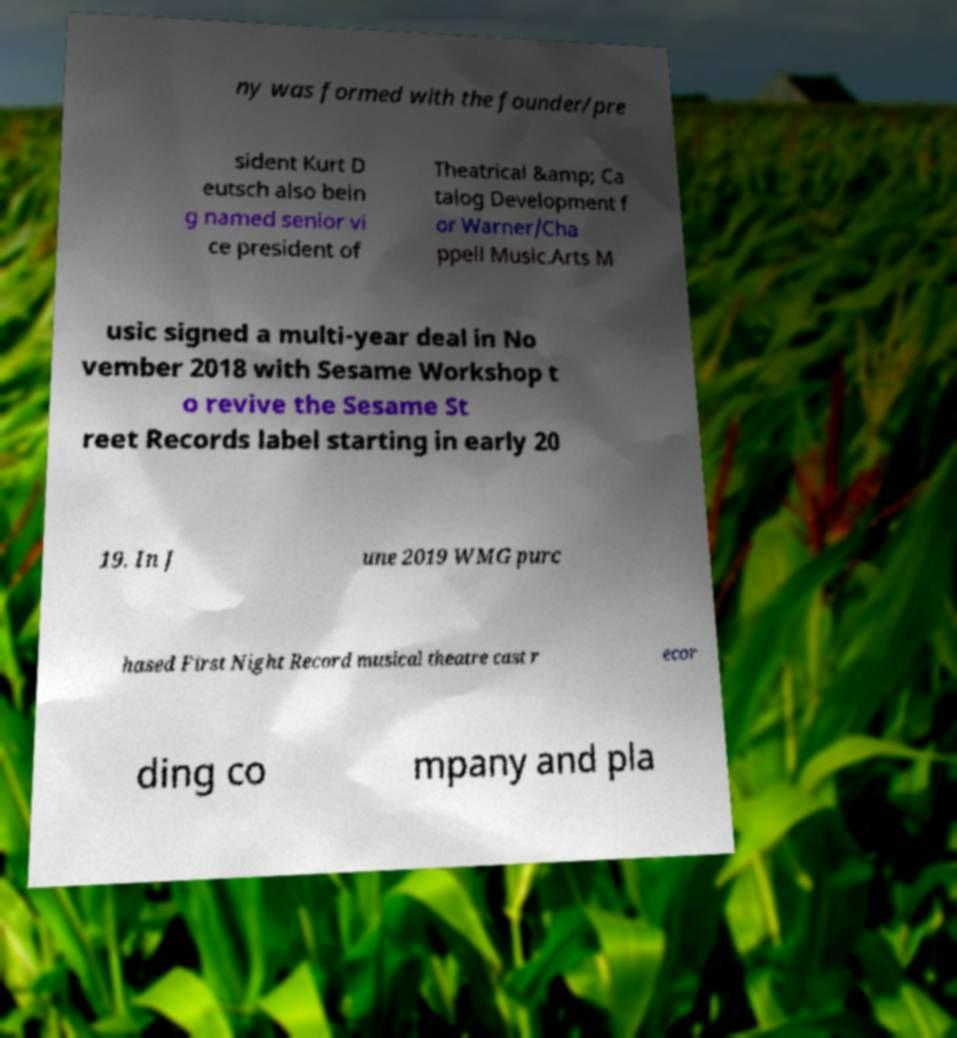What messages or text are displayed in this image? I need them in a readable, typed format. ny was formed with the founder/pre sident Kurt D eutsch also bein g named senior vi ce president of Theatrical &amp; Ca talog Development f or Warner/Cha ppell Music.Arts M usic signed a multi-year deal in No vember 2018 with Sesame Workshop t o revive the Sesame St reet Records label starting in early 20 19. In J une 2019 WMG purc hased First Night Record musical theatre cast r ecor ding co mpany and pla 